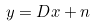Convert formula to latex. <formula><loc_0><loc_0><loc_500><loc_500>y = D x + n</formula> 